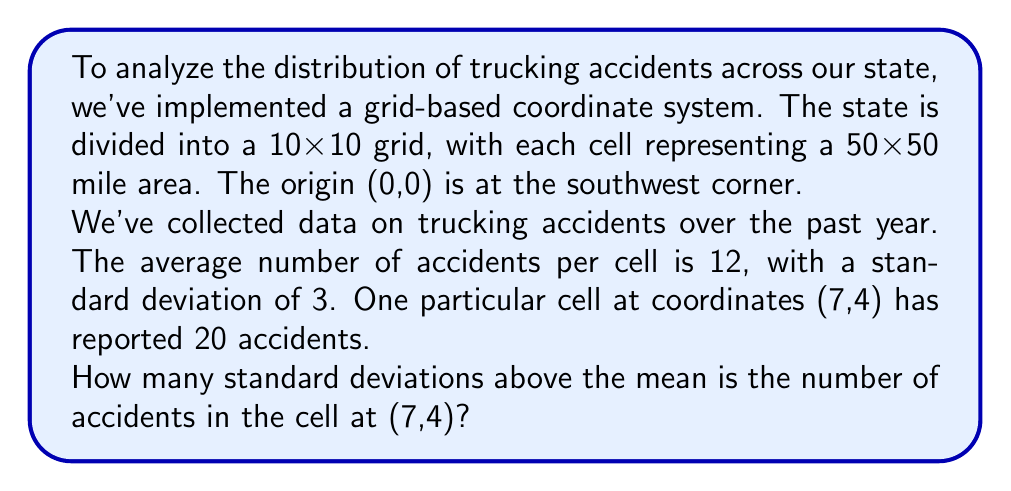Show me your answer to this math problem. To solve this problem, we need to follow these steps:

1. Identify the given information:
   - Mean (average) number of accidents per cell: $\mu = 12$
   - Standard deviation of accidents per cell: $\sigma = 3$
   - Number of accidents in the cell at (7,4): $x = 20$

2. Calculate the difference between the cell's value and the mean:
   $\text{Difference} = x - \mu = 20 - 12 = 8$

3. Calculate the number of standard deviations by dividing the difference by the standard deviation:
   $$\text{Number of standard deviations} = \frac{x - \mu}{\sigma} = \frac{20 - 12}{3} = \frac{8}{3} \approx 2.67$$

This calculation tells us how many standard deviations the cell's value is above (or below) the mean. In this case, it's above the mean because the result is positive.

The result of 2.67 standard deviations indicates that the number of accidents in the cell at (7,4) is significantly higher than the average, which could be an area of concern for implementing additional safety measures or investigating the causes of the higher accident rate in this region.
Answer: The number of accidents in the cell at (7,4) is approximately 2.67 standard deviations above the mean. 